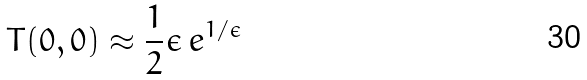Convert formula to latex. <formula><loc_0><loc_0><loc_500><loc_500>T ( 0 , 0 ) \approx \frac { 1 } { 2 } \epsilon \, { e } ^ { 1 / \epsilon } \,</formula> 